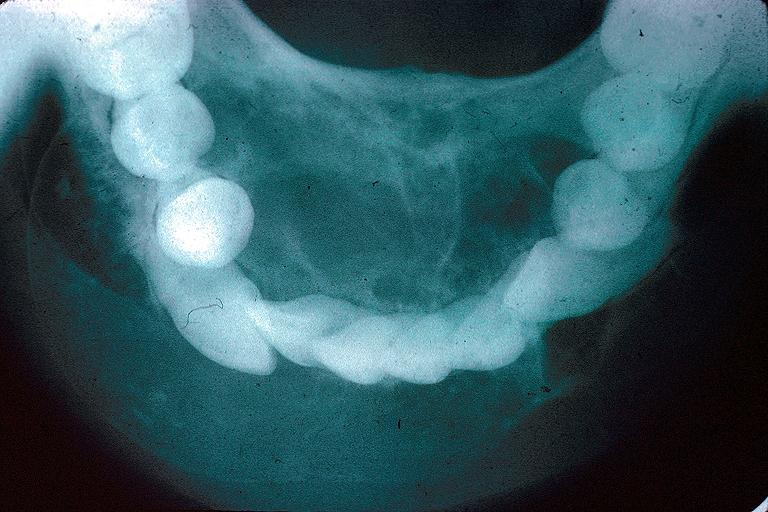s immunostain for growth hormone present?
Answer the question using a single word or phrase. No 